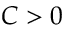Convert formula to latex. <formula><loc_0><loc_0><loc_500><loc_500>C > 0</formula> 